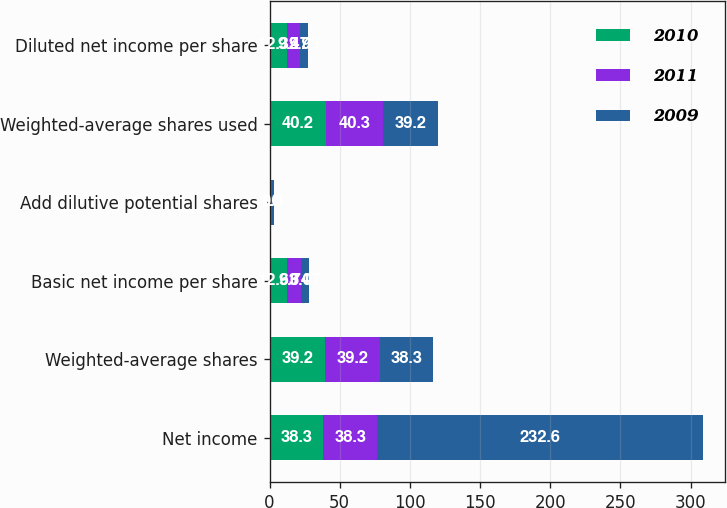Convert chart to OTSL. <chart><loc_0><loc_0><loc_500><loc_500><stacked_bar_chart><ecel><fcel>Net income<fcel>Weighted-average shares<fcel>Basic net income per share<fcel>Add dilutive potential shares<fcel>Weighted-average shares used<fcel>Diluted net income per share<nl><fcel>2010<fcel>38.3<fcel>39.2<fcel>12.63<fcel>1<fcel>40.2<fcel>12.32<nl><fcel>2011<fcel>38.3<fcel>39.2<fcel>9.74<fcel>1.1<fcel>40.3<fcel>9.47<nl><fcel>2009<fcel>232.6<fcel>38.3<fcel>6.07<fcel>0.9<fcel>39.2<fcel>5.93<nl></chart> 